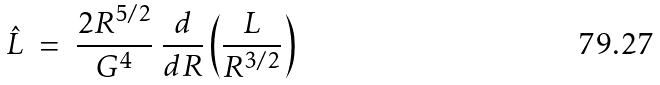<formula> <loc_0><loc_0><loc_500><loc_500>\hat { L } \ = \ \frac { 2 R ^ { 5 / 2 } } { G ^ { 4 } } \ \frac { d } { d R } \left ( \frac { L } { R ^ { 3 / 2 } } \right )</formula> 